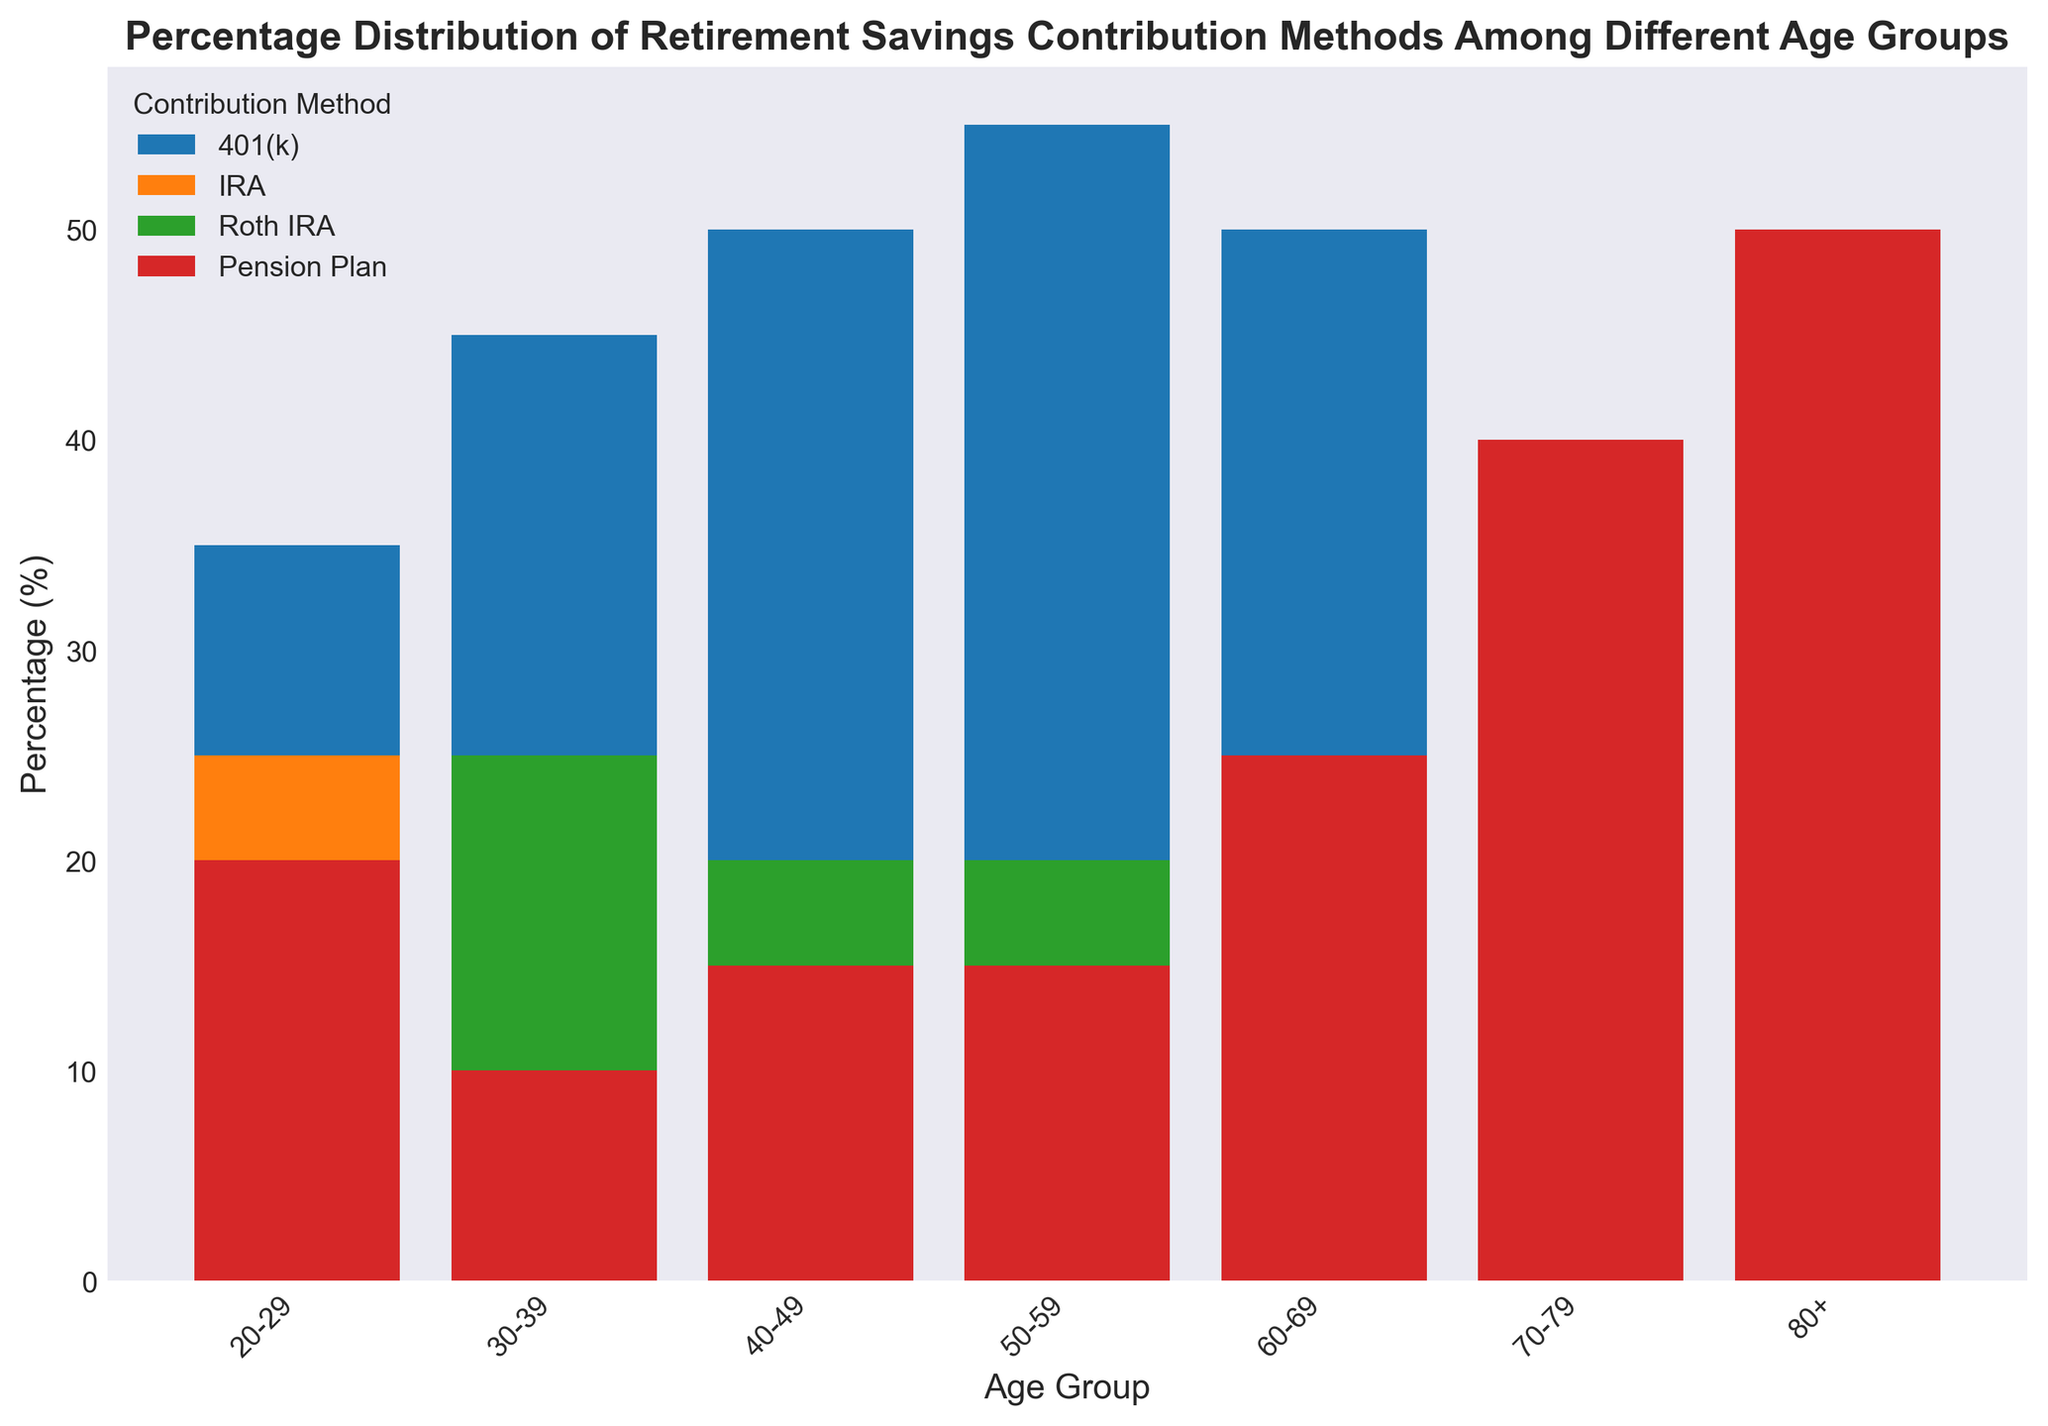What is the most common retirement savings method among people aged 40-49? To find the most common method, observe the data points for the 40-49 age group. The highest bar indicates the most common method.
Answer: 401(k) Which age group has the highest percentage contributing to a Pension Plan? Look at the heights of the bars representing Pension Plan contributions across all age groups. The tallest bar indicates the age group with the highest percentage.
Answer: 80+ Is there an age group where Roth IRA and IRA contributions are equal? Compare the heights of the bars for Roth IRA and IRA within each age group. Equality in height will indicate equal contributions.
Answer: 20-29 By how much does the percentage of people contributing to a 401(k) increase from the 20-29 age group to the 50-59 age group? Subtract the 401(k) contribution percentage in the 20-29 age group from the percentage in the 50-59 age group.
Answer: 20% What is the combined percentage of IRA and Roth IRA contributions for the 30-39 age group? Add the percentages of IRA and Roth IRA for the 30-39 age group together.
Answer: 45% Which age group has the lowest percentage of Roth IRA contributions, and what is that percentage? Identify the lowest bar corresponding to Roth IRA among all age groups and note the percentage.
Answer: 80+, 5% How does the percentage of people contributing to a Pension Plan change from the 60-69 age group to the 70-79 age group? Subtract the Pension Plan percentage for the 60-69 age group from that for the 70-79 age group.
Answer: Increase by 15% In which age group does the percentage of people contributing to an IRA exceed those contributing to a 401(k)? Compare the heights of the 401(k) and IRA bars within each age group. Identify if any age group has higher IRA contributions.
Answer: None Which retirement savings method sees a decline in contribution as the age increases from 50-59 to 80+? Observe the pattern of each method's bars from the 50-59 to the 80+ age group and identify any consistent decline.
Answer: 401(k) What is the total percentage of contributions accounted for by all methods in the 60-69 age group? Add the percentages of all methods in the 60-69 age group together.
Answer: 100% 